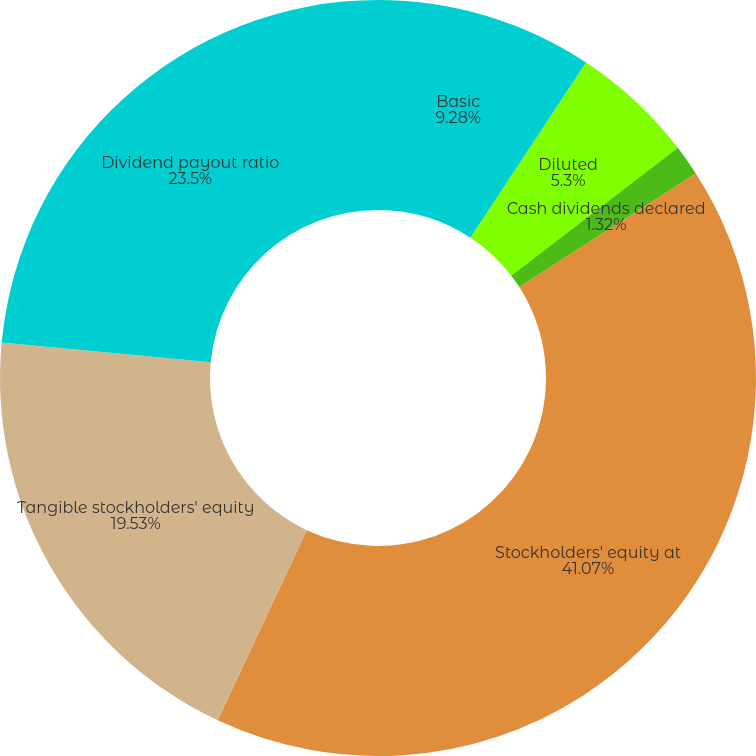Convert chart. <chart><loc_0><loc_0><loc_500><loc_500><pie_chart><fcel>Basic<fcel>Diluted<fcel>Cash dividends declared<fcel>Stockholders' equity at<fcel>Tangible stockholders' equity<fcel>Dividend payout ratio<nl><fcel>9.28%<fcel>5.3%<fcel>1.32%<fcel>41.07%<fcel>19.53%<fcel>23.5%<nl></chart> 